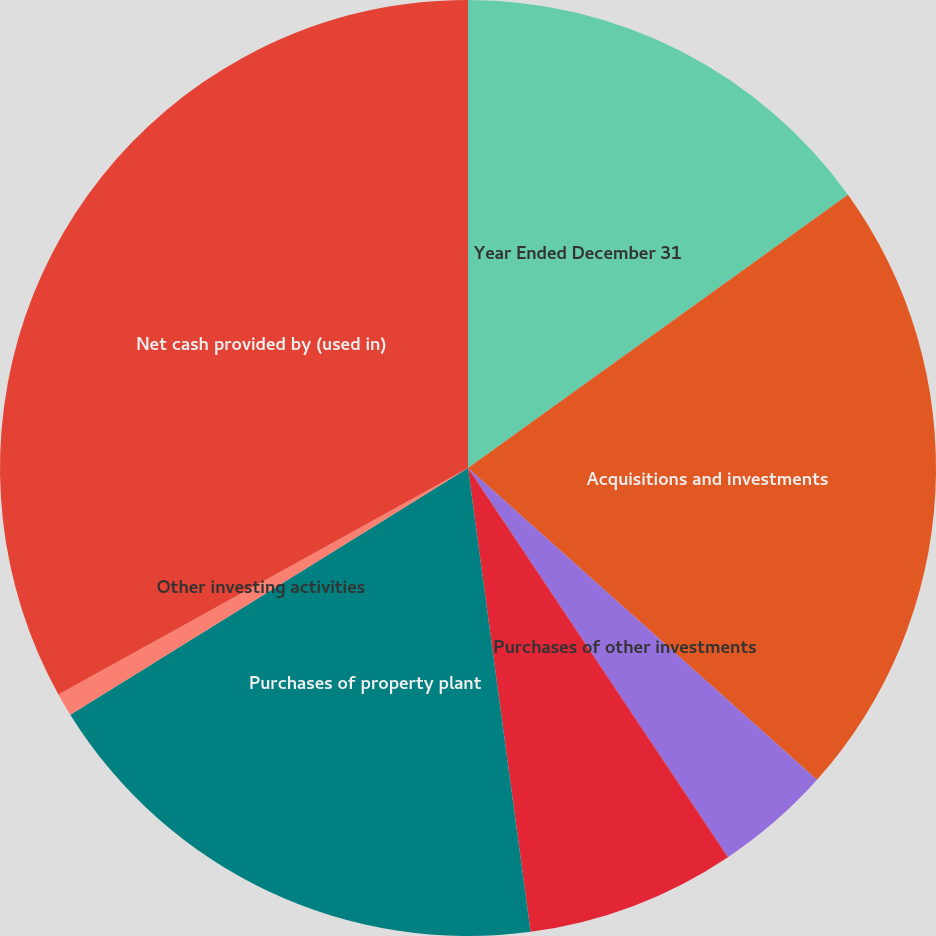<chart> <loc_0><loc_0><loc_500><loc_500><pie_chart><fcel>Year Ended December 31<fcel>Acquisitions and investments<fcel>Purchases of other investments<fcel>Proceeds from disposals of<fcel>Purchases of property plant<fcel>Other investing activities<fcel>Net cash provided by (used in)<nl><fcel>15.08%<fcel>21.53%<fcel>4.02%<fcel>7.24%<fcel>18.3%<fcel>0.8%<fcel>33.04%<nl></chart> 